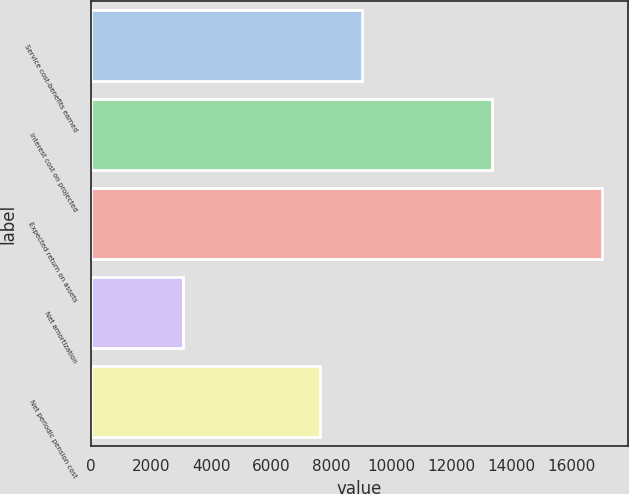Convert chart to OTSL. <chart><loc_0><loc_0><loc_500><loc_500><bar_chart><fcel>Service cost-benefits earned<fcel>Interest cost on projected<fcel>Expected return on assets<fcel>Net amortization<fcel>Net periodic pension cost<nl><fcel>9017<fcel>13360<fcel>17010<fcel>3050<fcel>7621<nl></chart> 